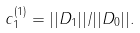Convert formula to latex. <formula><loc_0><loc_0><loc_500><loc_500>c _ { 1 } ^ { ( 1 ) } = | | D _ { 1 } | | / | | D _ { 0 } | | .</formula> 